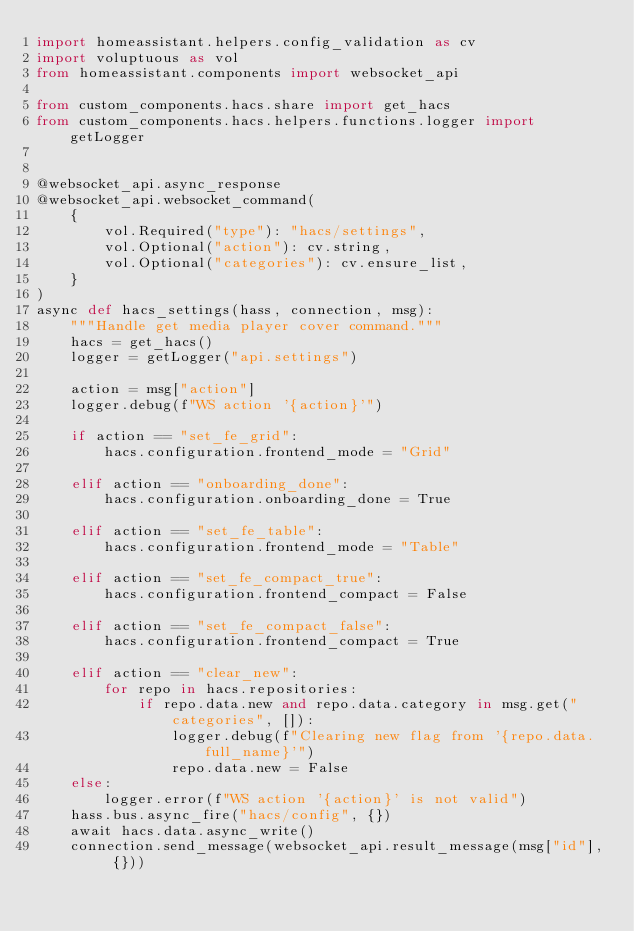Convert code to text. <code><loc_0><loc_0><loc_500><loc_500><_Python_>import homeassistant.helpers.config_validation as cv
import voluptuous as vol
from homeassistant.components import websocket_api

from custom_components.hacs.share import get_hacs
from custom_components.hacs.helpers.functions.logger import getLogger


@websocket_api.async_response
@websocket_api.websocket_command(
    {
        vol.Required("type"): "hacs/settings",
        vol.Optional("action"): cv.string,
        vol.Optional("categories"): cv.ensure_list,
    }
)
async def hacs_settings(hass, connection, msg):
    """Handle get media player cover command."""
    hacs = get_hacs()
    logger = getLogger("api.settings")

    action = msg["action"]
    logger.debug(f"WS action '{action}'")

    if action == "set_fe_grid":
        hacs.configuration.frontend_mode = "Grid"

    elif action == "onboarding_done":
        hacs.configuration.onboarding_done = True

    elif action == "set_fe_table":
        hacs.configuration.frontend_mode = "Table"

    elif action == "set_fe_compact_true":
        hacs.configuration.frontend_compact = False

    elif action == "set_fe_compact_false":
        hacs.configuration.frontend_compact = True

    elif action == "clear_new":
        for repo in hacs.repositories:
            if repo.data.new and repo.data.category in msg.get("categories", []):
                logger.debug(f"Clearing new flag from '{repo.data.full_name}'")
                repo.data.new = False
    else:
        logger.error(f"WS action '{action}' is not valid")
    hass.bus.async_fire("hacs/config", {})
    await hacs.data.async_write()
    connection.send_message(websocket_api.result_message(msg["id"], {}))
</code> 